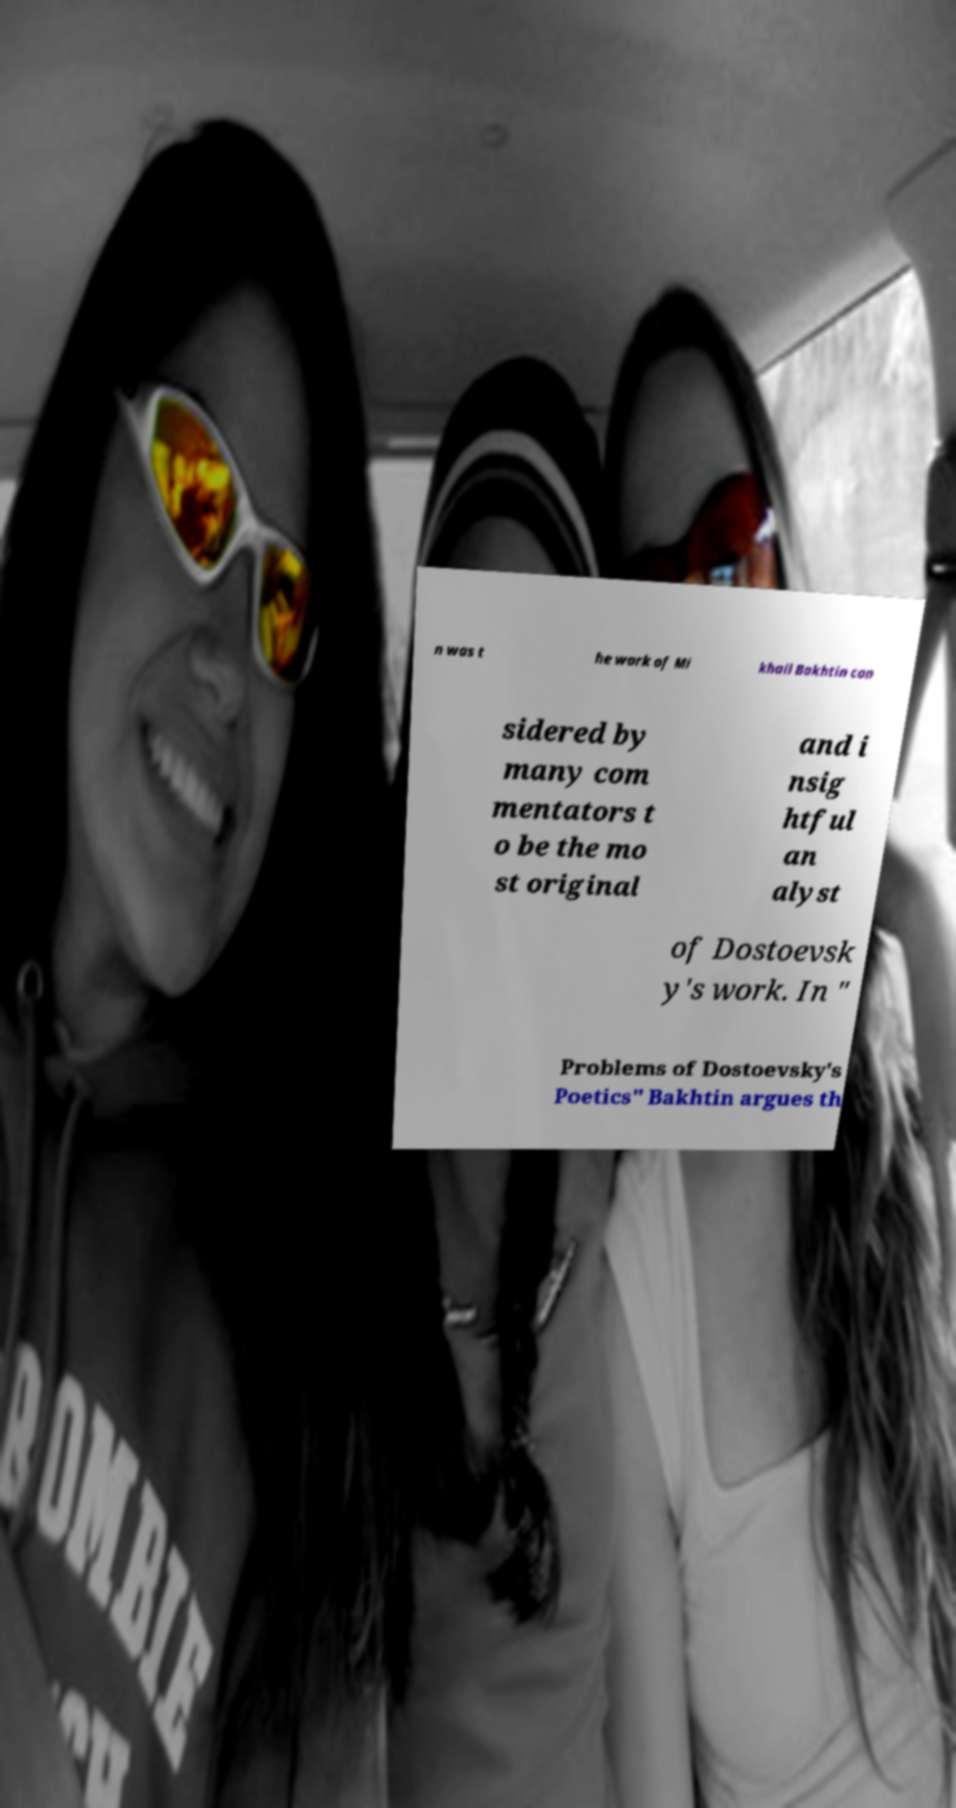Could you extract and type out the text from this image? n was t he work of Mi khail Bakhtin con sidered by many com mentators t o be the mo st original and i nsig htful an alyst of Dostoevsk y's work. In " Problems of Dostoevsky's Poetics" Bakhtin argues th 